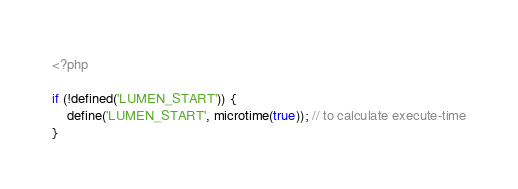<code> <loc_0><loc_0><loc_500><loc_500><_PHP_><?php

if (!defined('LUMEN_START')) {
    define('LUMEN_START', microtime(true)); // to calculate execute-time
}
</code> 